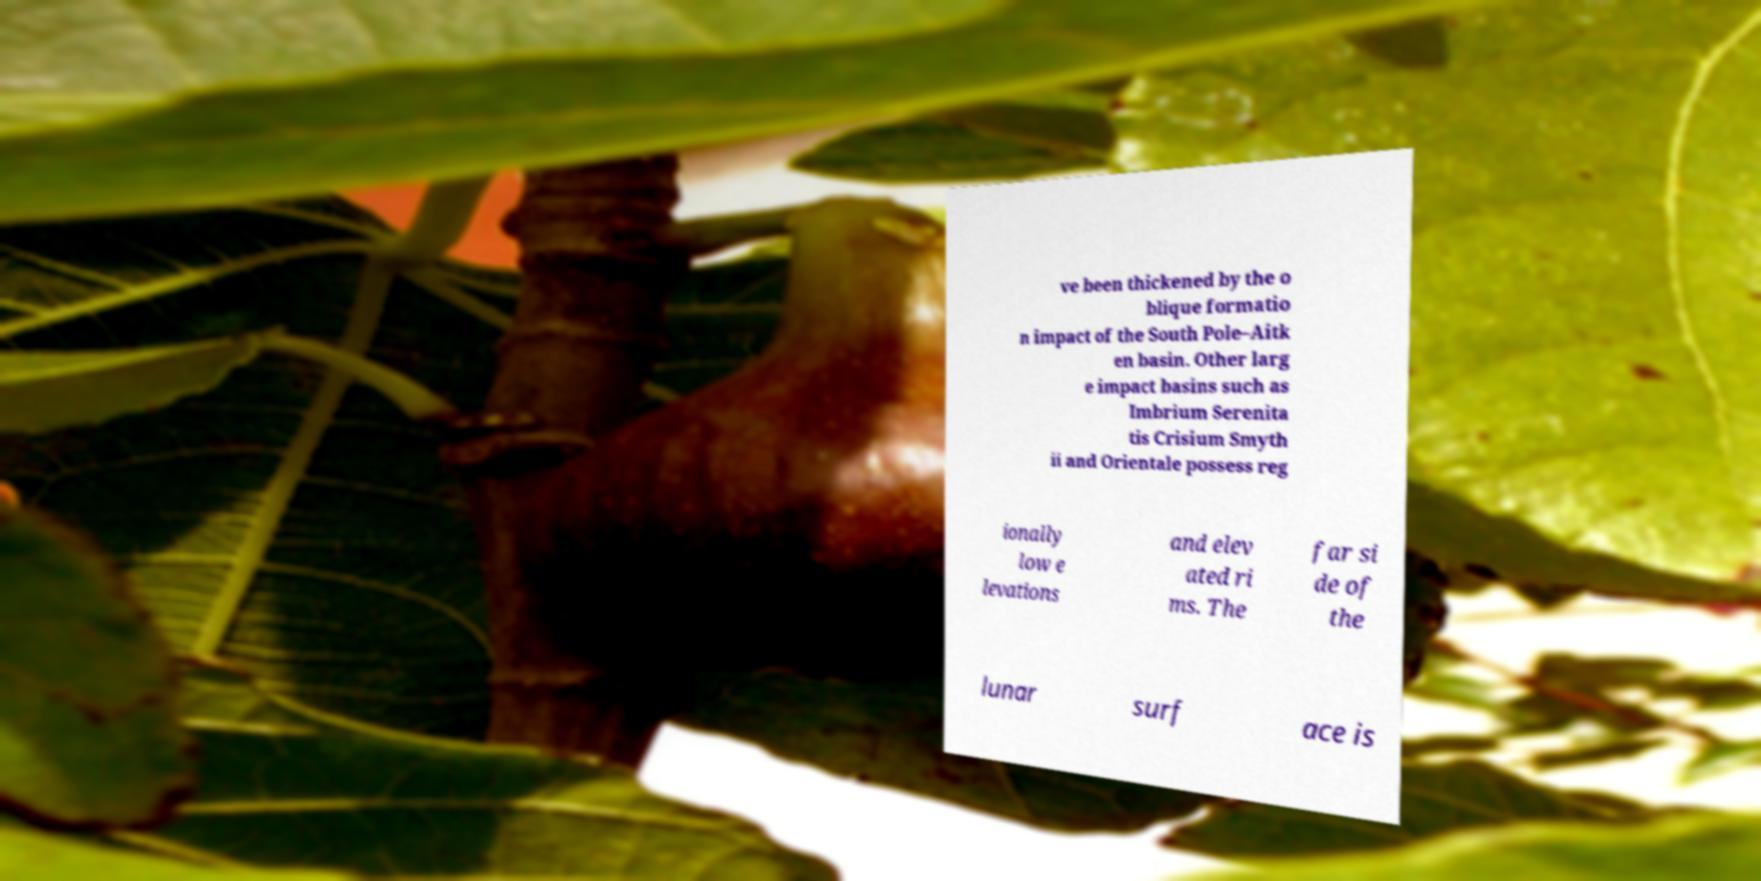Can you read and provide the text displayed in the image?This photo seems to have some interesting text. Can you extract and type it out for me? ve been thickened by the o blique formatio n impact of the South Pole–Aitk en basin. Other larg e impact basins such as Imbrium Serenita tis Crisium Smyth ii and Orientale possess reg ionally low e levations and elev ated ri ms. The far si de of the lunar surf ace is 